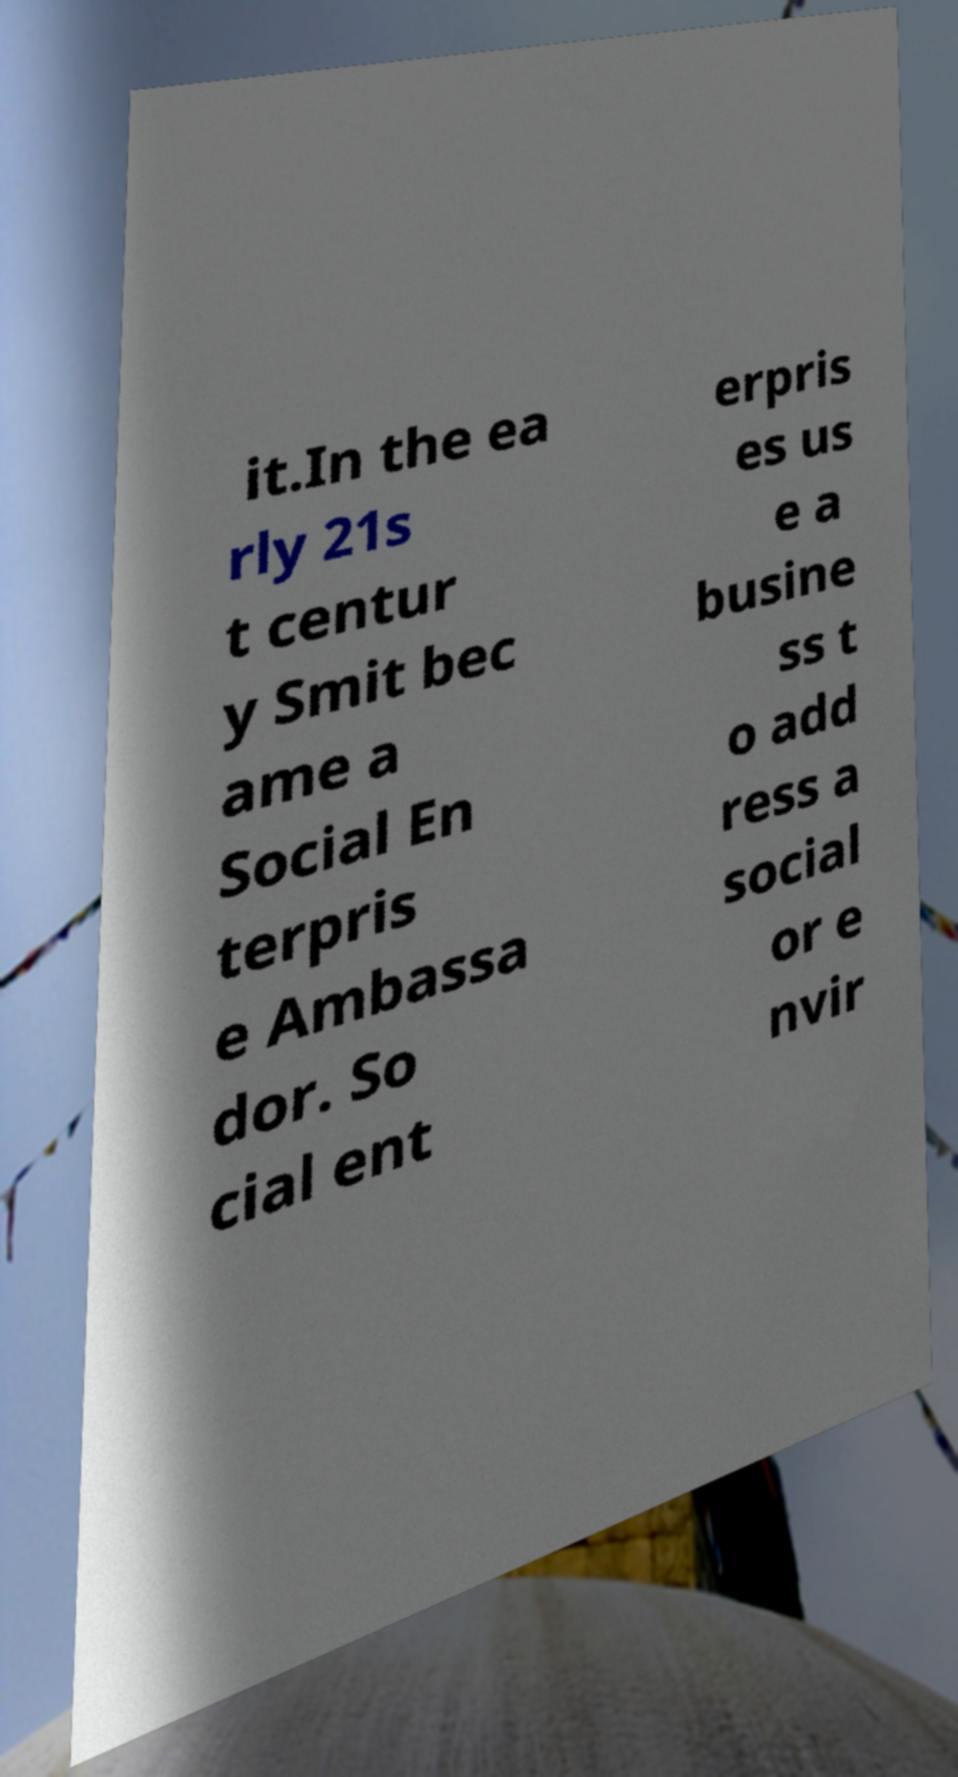Please identify and transcribe the text found in this image. it.In the ea rly 21s t centur y Smit bec ame a Social En terpris e Ambassa dor. So cial ent erpris es us e a busine ss t o add ress a social or e nvir 